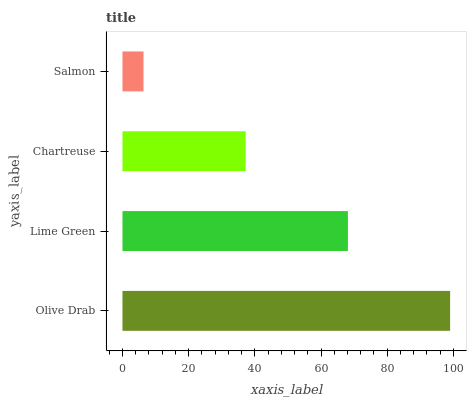Is Salmon the minimum?
Answer yes or no. Yes. Is Olive Drab the maximum?
Answer yes or no. Yes. Is Lime Green the minimum?
Answer yes or no. No. Is Lime Green the maximum?
Answer yes or no. No. Is Olive Drab greater than Lime Green?
Answer yes or no. Yes. Is Lime Green less than Olive Drab?
Answer yes or no. Yes. Is Lime Green greater than Olive Drab?
Answer yes or no. No. Is Olive Drab less than Lime Green?
Answer yes or no. No. Is Lime Green the high median?
Answer yes or no. Yes. Is Chartreuse the low median?
Answer yes or no. Yes. Is Olive Drab the high median?
Answer yes or no. No. Is Lime Green the low median?
Answer yes or no. No. 